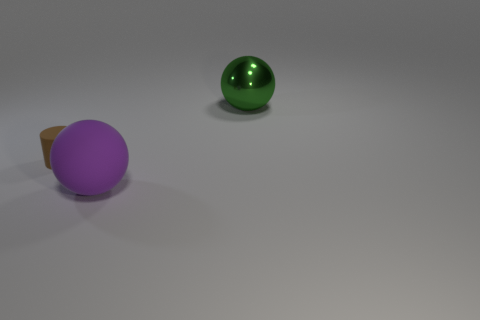There is a small rubber thing; does it have the same shape as the large object on the right side of the purple rubber ball?
Provide a short and direct response. No. Is the number of brown rubber cylinders that are in front of the cylinder greater than the number of tiny purple matte cylinders?
Your response must be concise. No. Is the number of purple things that are right of the large green metallic object less than the number of purple matte balls?
Ensure brevity in your answer.  Yes. What number of spheres have the same color as the small cylinder?
Your answer should be very brief. 0. There is a object that is both left of the green metal object and to the right of the small rubber cylinder; what material is it?
Make the answer very short. Rubber. Does the big thing in front of the metal thing have the same color as the matte cylinder in front of the metallic thing?
Keep it short and to the point. No. What number of blue things are small cylinders or big metallic balls?
Keep it short and to the point. 0. Are there fewer matte balls that are on the right side of the green metallic object than brown cylinders behind the brown rubber cylinder?
Provide a short and direct response. No. Is there a gray metallic cylinder that has the same size as the green object?
Your answer should be very brief. No. Does the ball left of the metal sphere have the same size as the big green shiny thing?
Provide a succinct answer. Yes. 